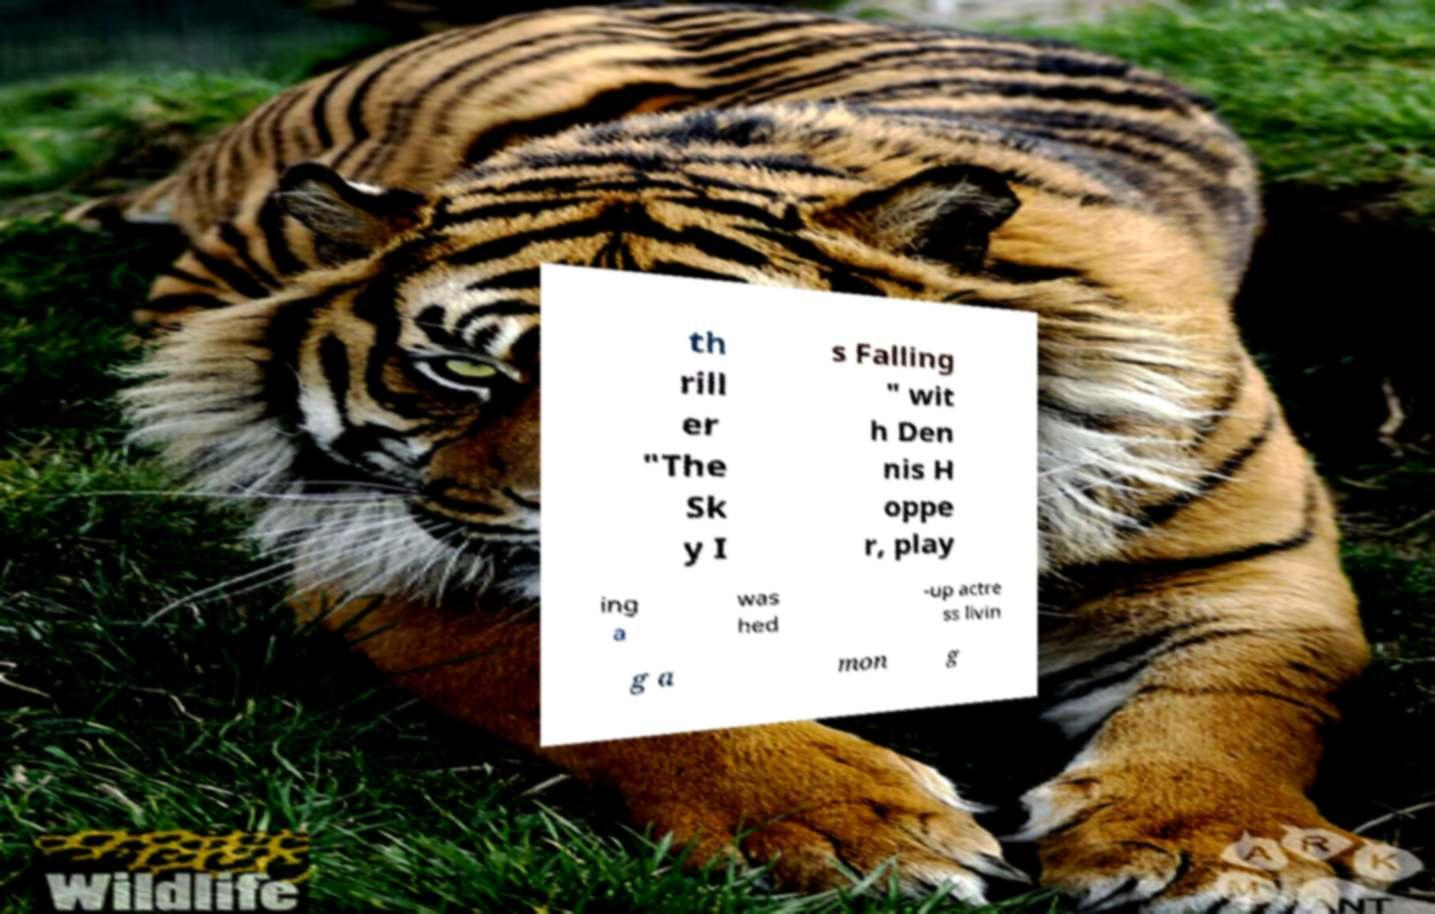Could you extract and type out the text from this image? th rill er "The Sk y I s Falling " wit h Den nis H oppe r, play ing a was hed -up actre ss livin g a mon g 